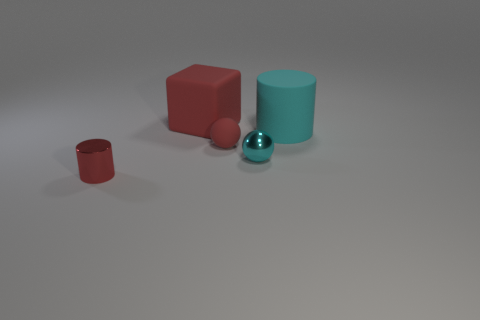What number of other objects are the same color as the small shiny ball?
Keep it short and to the point. 1. There is a cyan matte cylinder that is on the right side of the red thing that is in front of the small cyan ball; what is its size?
Offer a terse response. Large. Are there more tiny cyan spheres in front of the large cyan matte cylinder than red rubber objects that are in front of the red cylinder?
Offer a very short reply. Yes. How many cylinders are either large cyan rubber things or rubber objects?
Provide a succinct answer. 1. There is a red thing that is in front of the rubber ball; is its shape the same as the big cyan rubber object?
Your answer should be very brief. Yes. What is the color of the shiny sphere?
Offer a very short reply. Cyan. What is the color of the small thing that is the same shape as the large cyan thing?
Your response must be concise. Red. What number of tiny matte objects are the same shape as the large red object?
Provide a short and direct response. 0. How many things are either small purple matte balls or objects that are behind the shiny sphere?
Make the answer very short. 3. Is the color of the large rubber cube the same as the cylinder to the right of the matte sphere?
Keep it short and to the point. No. 